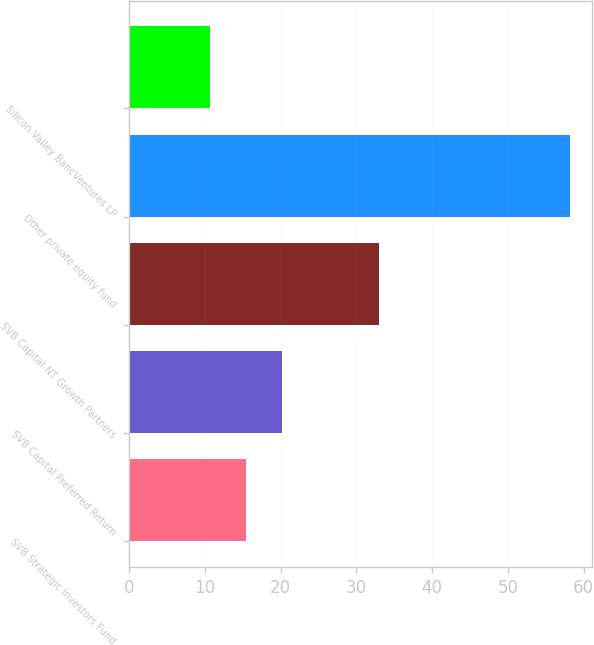Convert chart to OTSL. <chart><loc_0><loc_0><loc_500><loc_500><bar_chart><fcel>SVB Strategic Investors Fund<fcel>SVB Capital Preferred Return<fcel>SVB Capital-NT Growth Partners<fcel>Other private equity fund<fcel>Silicon Valley BancVentures LP<nl><fcel>15.45<fcel>20.2<fcel>33<fcel>58.2<fcel>10.7<nl></chart> 